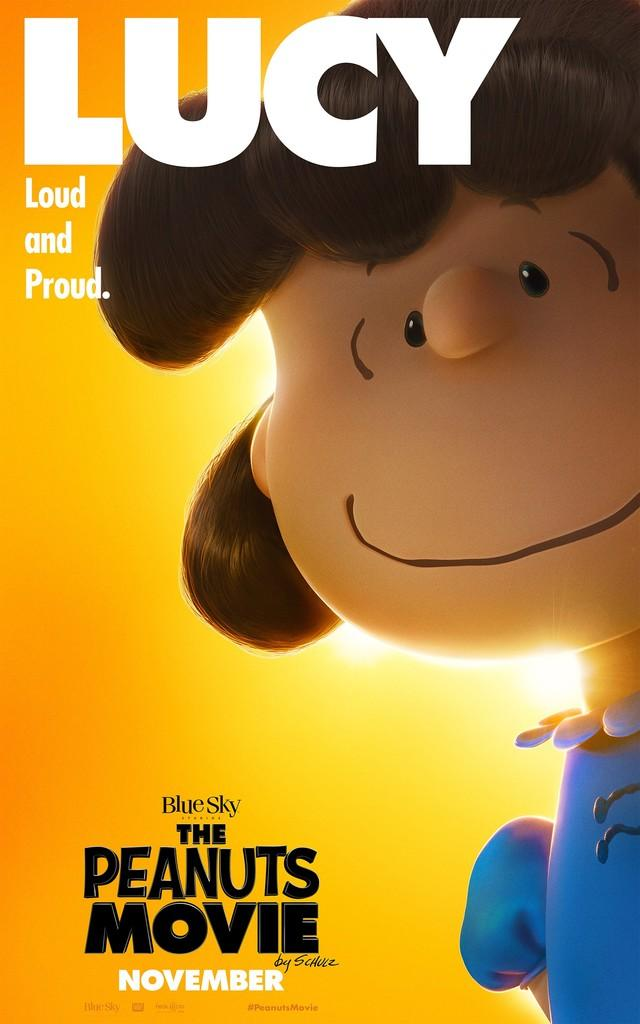<image>
Create a compact narrative representing the image presented. movie poster for the peanuts movie with a picture of lucy 